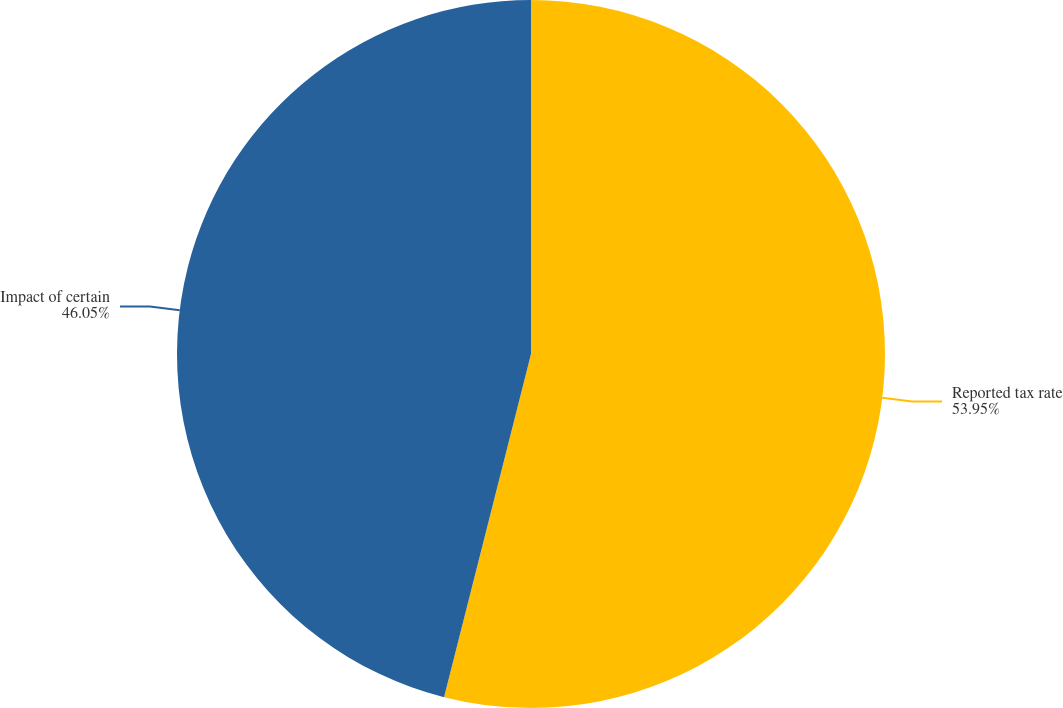Convert chart. <chart><loc_0><loc_0><loc_500><loc_500><pie_chart><fcel>Reported tax rate<fcel>Impact of certain<nl><fcel>53.95%<fcel>46.05%<nl></chart> 